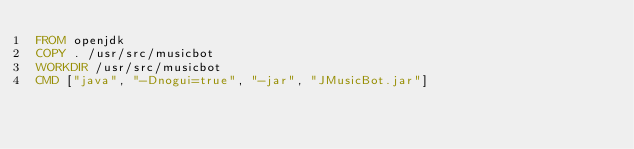Convert code to text. <code><loc_0><loc_0><loc_500><loc_500><_Dockerfile_>FROM openjdk
COPY . /usr/src/musicbot
WORKDIR /usr/src/musicbot
CMD ["java", "-Dnogui=true", "-jar", "JMusicBot.jar"]
</code> 